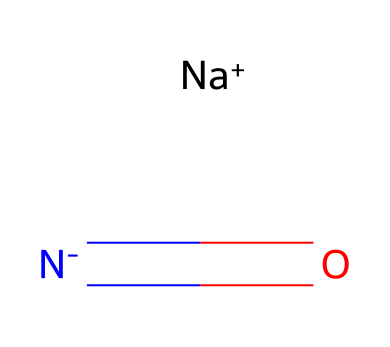What is the molecular formula of sodium nitrite? The SMILES representation indicates the presence of sodium (Na), nitrogen (N), and oxygen (O) atoms. By analyzing the components in the chemical structure, we can deduce the molecular formula which is NaNO2.
Answer: NaNO2 How many oxygen atoms are in sodium nitrite? The SMILES representation shows the presence of one nitrogen atom bonded to two oxygen atoms. Counting the oxygen atoms yields a total of two.
Answer: 2 What type of bond connects nitrogen and oxygen in sodium nitrite? In the SMILES notation, the notation includes a double bond between nitrogen and one of the oxygen atoms, indicating a strong covalent bond.
Answer: double bond What is the charge on sodium in sodium nitrite? The representation indicates sodium is in a cationic form, shown as [Na+], which indicates it carries a positive charge.
Answer: +1 Why is sodium nitrite used in food preservation? Sodium nitrite is used in food preservation primarily due to its ability to inhibit the growth of certain bacteria and to maintain color in cured meats, which can be inferred from its properties as a reducing agent.
Answer: inhibits bacteria How does sodium nitrite contribute to the preservation of historical documents? sodium nitrite can prevent microbial decay and oxidation in historical documents, acting as a preservative by its chemical properties that inhibit deterioration processes.
Answer: prevents decay What function does the nitrogen atom serve in sodium nitrite? The nitrogen atom in sodium nitrite plays a crucial role in its chemical reactivity, particularly in its ability to form nitrosamines, which are relevant in food preservation and protection against deterioration.
Answer: reactivity 